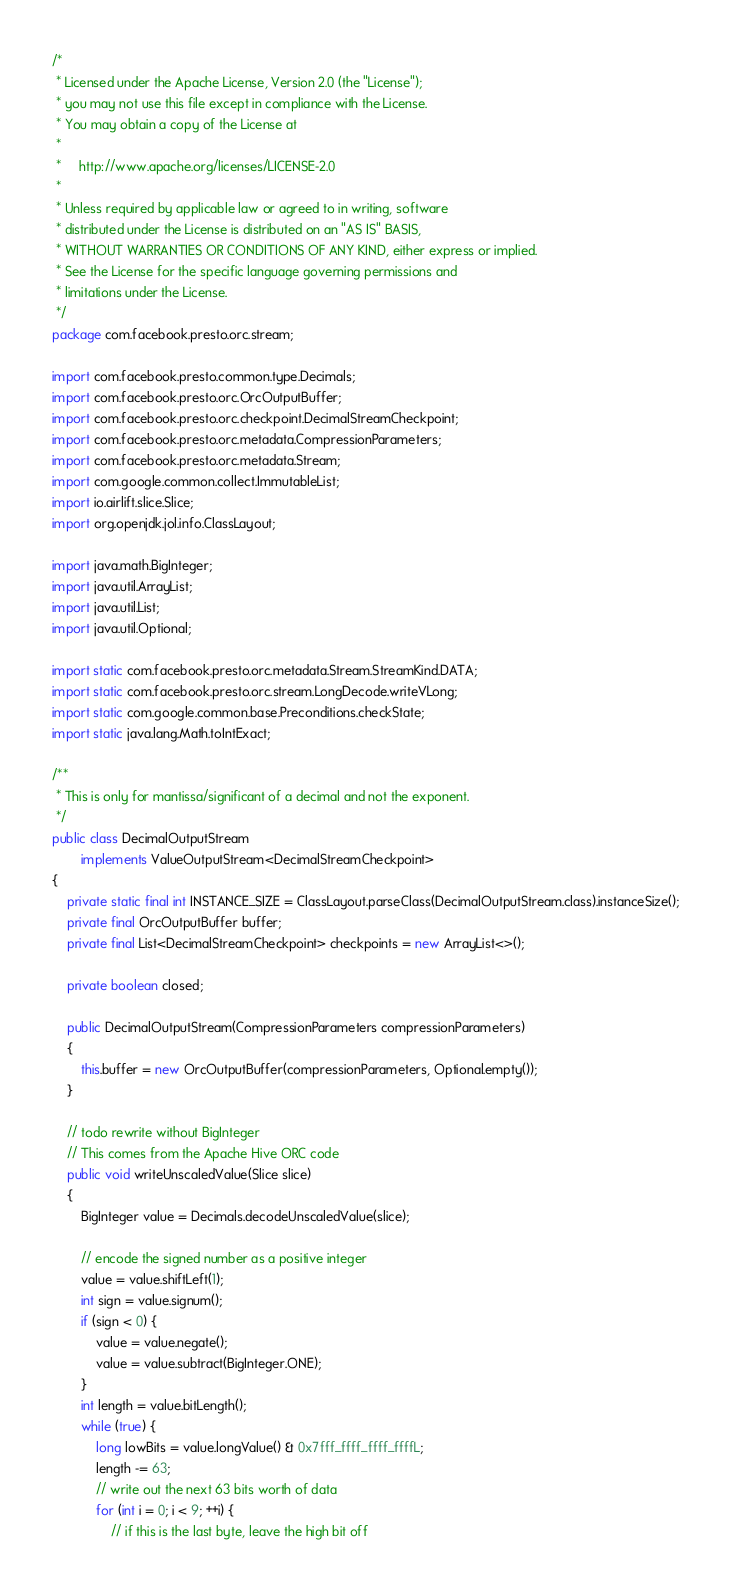<code> <loc_0><loc_0><loc_500><loc_500><_Java_>/*
 * Licensed under the Apache License, Version 2.0 (the "License");
 * you may not use this file except in compliance with the License.
 * You may obtain a copy of the License at
 *
 *     http://www.apache.org/licenses/LICENSE-2.0
 *
 * Unless required by applicable law or agreed to in writing, software
 * distributed under the License is distributed on an "AS IS" BASIS,
 * WITHOUT WARRANTIES OR CONDITIONS OF ANY KIND, either express or implied.
 * See the License for the specific language governing permissions and
 * limitations under the License.
 */
package com.facebook.presto.orc.stream;

import com.facebook.presto.common.type.Decimals;
import com.facebook.presto.orc.OrcOutputBuffer;
import com.facebook.presto.orc.checkpoint.DecimalStreamCheckpoint;
import com.facebook.presto.orc.metadata.CompressionParameters;
import com.facebook.presto.orc.metadata.Stream;
import com.google.common.collect.ImmutableList;
import io.airlift.slice.Slice;
import org.openjdk.jol.info.ClassLayout;

import java.math.BigInteger;
import java.util.ArrayList;
import java.util.List;
import java.util.Optional;

import static com.facebook.presto.orc.metadata.Stream.StreamKind.DATA;
import static com.facebook.presto.orc.stream.LongDecode.writeVLong;
import static com.google.common.base.Preconditions.checkState;
import static java.lang.Math.toIntExact;

/**
 * This is only for mantissa/significant of a decimal and not the exponent.
 */
public class DecimalOutputStream
        implements ValueOutputStream<DecimalStreamCheckpoint>
{
    private static final int INSTANCE_SIZE = ClassLayout.parseClass(DecimalOutputStream.class).instanceSize();
    private final OrcOutputBuffer buffer;
    private final List<DecimalStreamCheckpoint> checkpoints = new ArrayList<>();

    private boolean closed;

    public DecimalOutputStream(CompressionParameters compressionParameters)
    {
        this.buffer = new OrcOutputBuffer(compressionParameters, Optional.empty());
    }

    // todo rewrite without BigInteger
    // This comes from the Apache Hive ORC code
    public void writeUnscaledValue(Slice slice)
    {
        BigInteger value = Decimals.decodeUnscaledValue(slice);

        // encode the signed number as a positive integer
        value = value.shiftLeft(1);
        int sign = value.signum();
        if (sign < 0) {
            value = value.negate();
            value = value.subtract(BigInteger.ONE);
        }
        int length = value.bitLength();
        while (true) {
            long lowBits = value.longValue() & 0x7fff_ffff_ffff_ffffL;
            length -= 63;
            // write out the next 63 bits worth of data
            for (int i = 0; i < 9; ++i) {
                // if this is the last byte, leave the high bit off</code> 